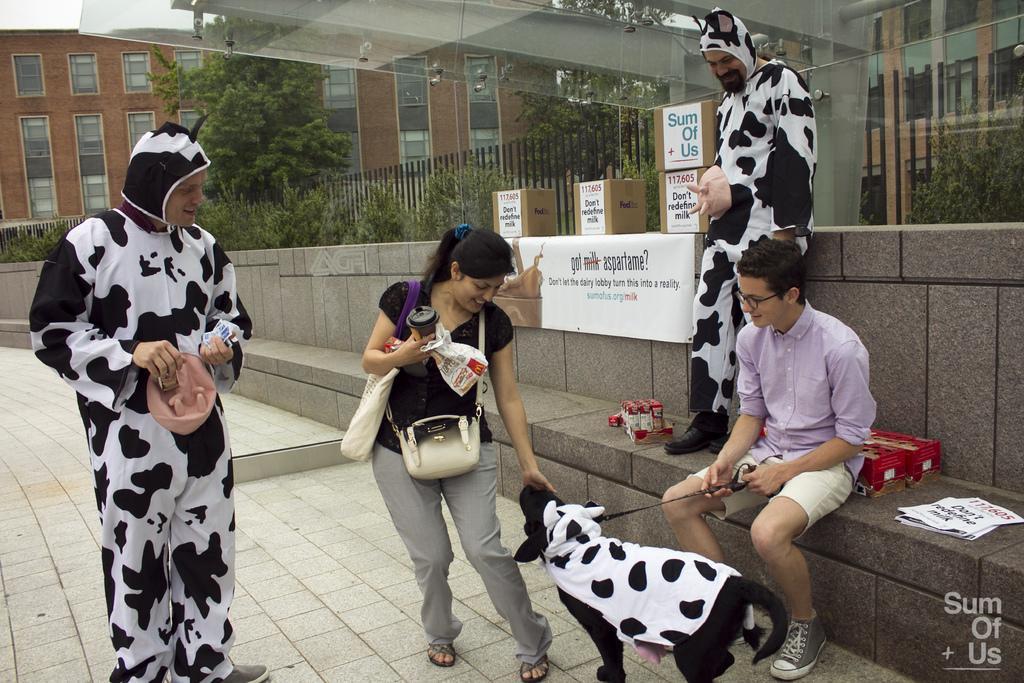Please provide a concise description of this image. In this image I see 3 men and a woman, who are smiling and I see a dog over here and all of them are on the path. I can also see few things here. In the background I see buildings, boxes and the trees. 